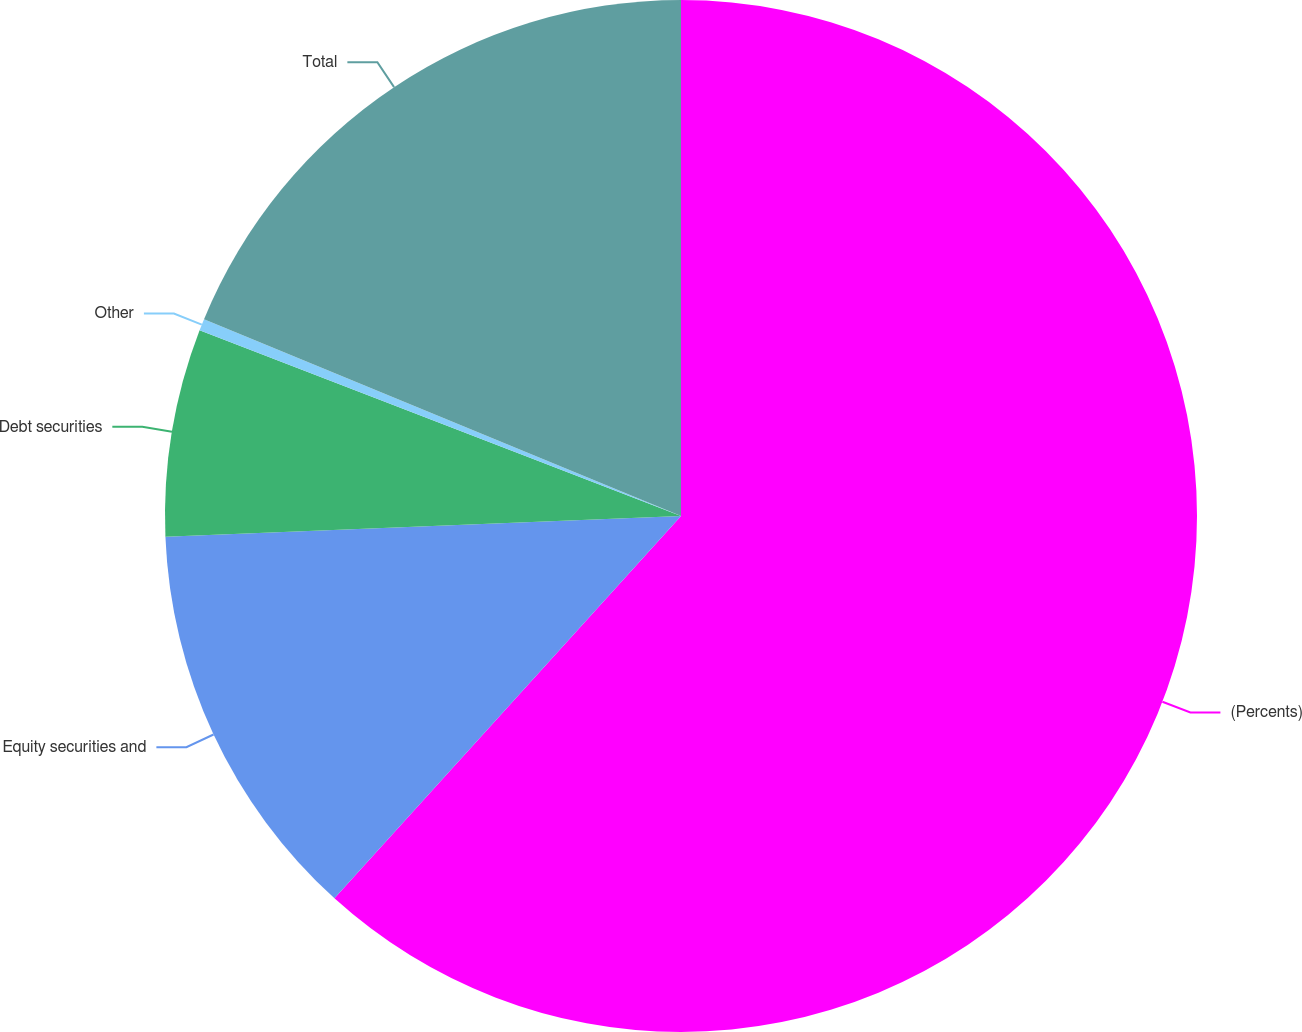<chart> <loc_0><loc_0><loc_500><loc_500><pie_chart><fcel>(Percents)<fcel>Equity securities and<fcel>Debt securities<fcel>Other<fcel>Total<nl><fcel>61.72%<fcel>12.64%<fcel>6.5%<fcel>0.37%<fcel>18.77%<nl></chart> 